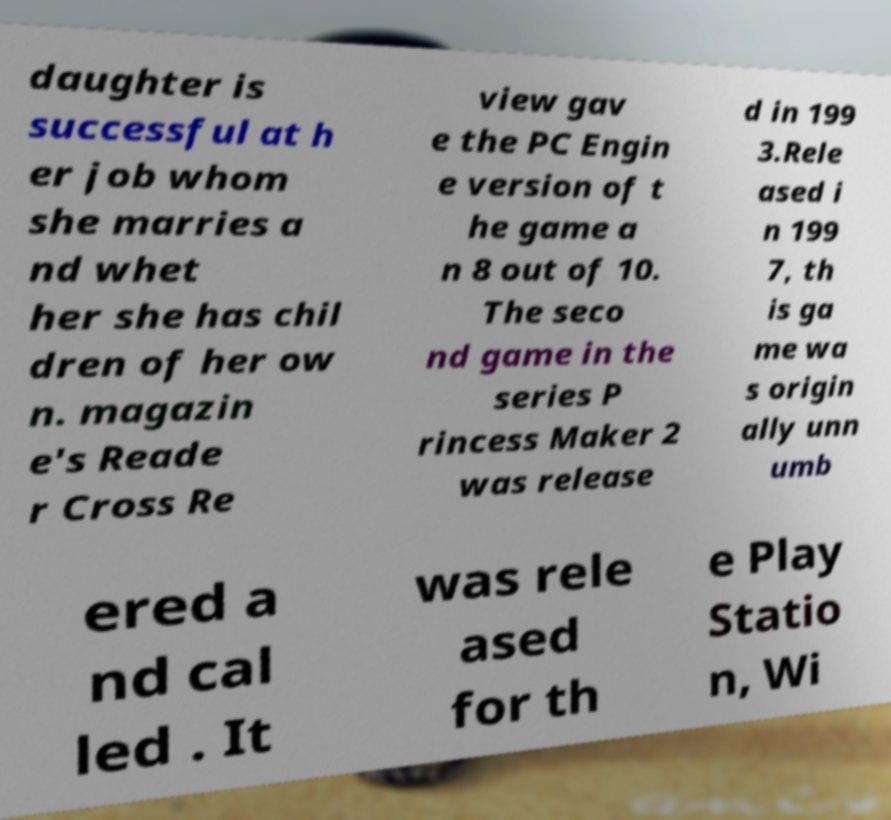Can you accurately transcribe the text from the provided image for me? daughter is successful at h er job whom she marries a nd whet her she has chil dren of her ow n. magazin e's Reade r Cross Re view gav e the PC Engin e version of t he game a n 8 out of 10. The seco nd game in the series P rincess Maker 2 was release d in 199 3.Rele ased i n 199 7, th is ga me wa s origin ally unn umb ered a nd cal led . It was rele ased for th e Play Statio n, Wi 